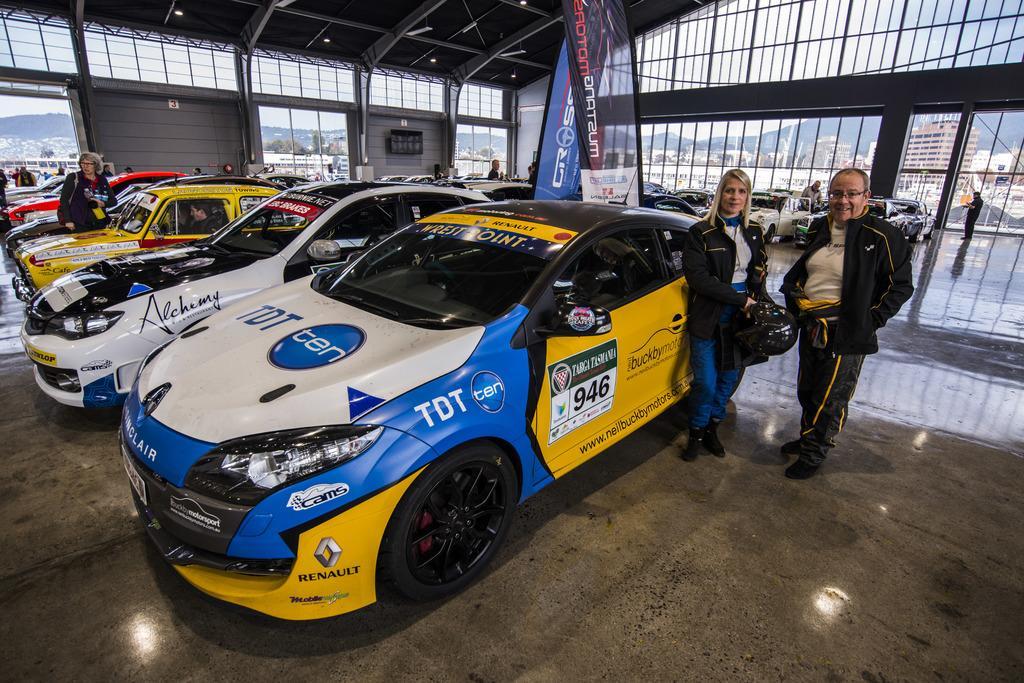How would you summarize this image in a sentence or two? In the foreground of this image, there is a woman and a man standing on the floor where a woman is holding a helmet. Behind them, there are few cars, flags and few people under the shed. In the background, there are buildings, trees, mountains and the sky. 